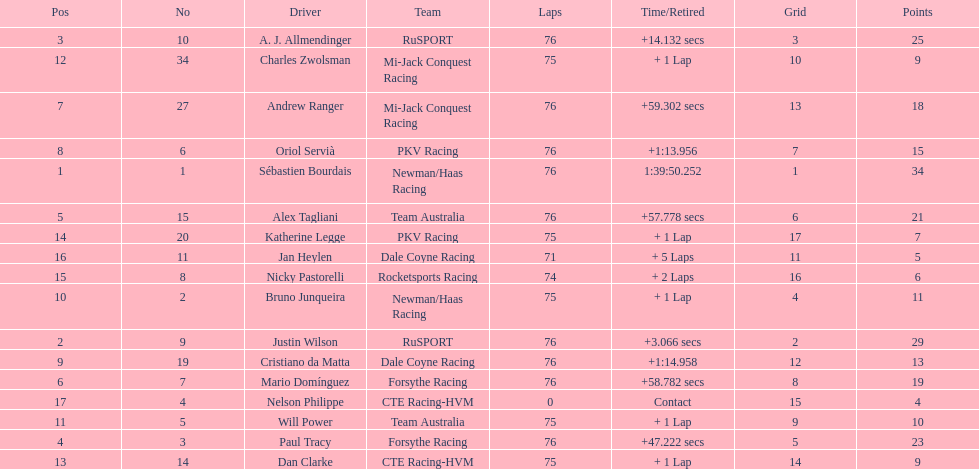What is the total point difference between the driver who received the most points and the driver who received the least? 30. 